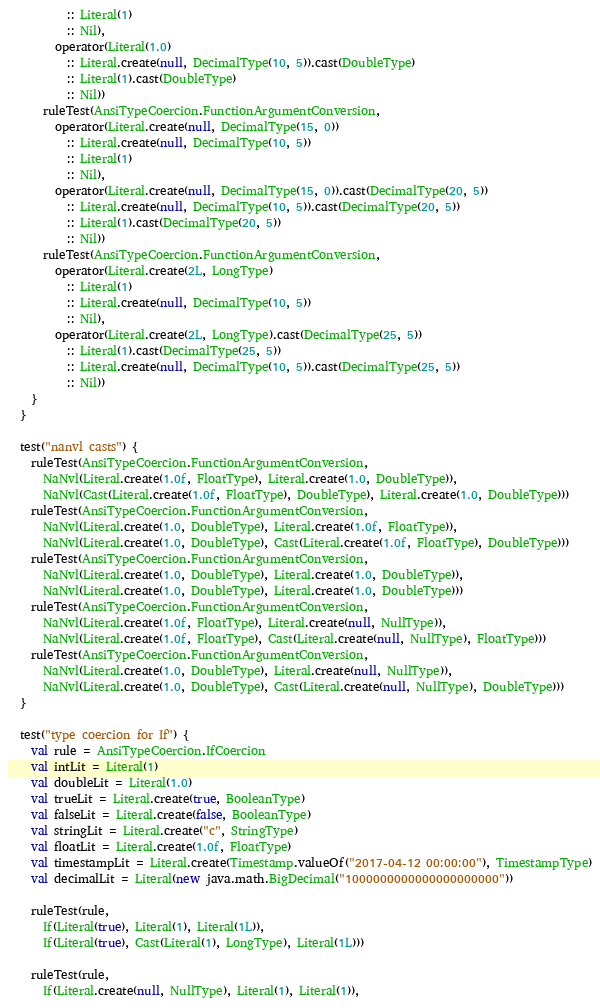<code> <loc_0><loc_0><loc_500><loc_500><_Scala_>          :: Literal(1)
          :: Nil),
        operator(Literal(1.0)
          :: Literal.create(null, DecimalType(10, 5)).cast(DoubleType)
          :: Literal(1).cast(DoubleType)
          :: Nil))
      ruleTest(AnsiTypeCoercion.FunctionArgumentConversion,
        operator(Literal.create(null, DecimalType(15, 0))
          :: Literal.create(null, DecimalType(10, 5))
          :: Literal(1)
          :: Nil),
        operator(Literal.create(null, DecimalType(15, 0)).cast(DecimalType(20, 5))
          :: Literal.create(null, DecimalType(10, 5)).cast(DecimalType(20, 5))
          :: Literal(1).cast(DecimalType(20, 5))
          :: Nil))
      ruleTest(AnsiTypeCoercion.FunctionArgumentConversion,
        operator(Literal.create(2L, LongType)
          :: Literal(1)
          :: Literal.create(null, DecimalType(10, 5))
          :: Nil),
        operator(Literal.create(2L, LongType).cast(DecimalType(25, 5))
          :: Literal(1).cast(DecimalType(25, 5))
          :: Literal.create(null, DecimalType(10, 5)).cast(DecimalType(25, 5))
          :: Nil))
    }
  }

  test("nanvl casts") {
    ruleTest(AnsiTypeCoercion.FunctionArgumentConversion,
      NaNvl(Literal.create(1.0f, FloatType), Literal.create(1.0, DoubleType)),
      NaNvl(Cast(Literal.create(1.0f, FloatType), DoubleType), Literal.create(1.0, DoubleType)))
    ruleTest(AnsiTypeCoercion.FunctionArgumentConversion,
      NaNvl(Literal.create(1.0, DoubleType), Literal.create(1.0f, FloatType)),
      NaNvl(Literal.create(1.0, DoubleType), Cast(Literal.create(1.0f, FloatType), DoubleType)))
    ruleTest(AnsiTypeCoercion.FunctionArgumentConversion,
      NaNvl(Literal.create(1.0, DoubleType), Literal.create(1.0, DoubleType)),
      NaNvl(Literal.create(1.0, DoubleType), Literal.create(1.0, DoubleType)))
    ruleTest(AnsiTypeCoercion.FunctionArgumentConversion,
      NaNvl(Literal.create(1.0f, FloatType), Literal.create(null, NullType)),
      NaNvl(Literal.create(1.0f, FloatType), Cast(Literal.create(null, NullType), FloatType)))
    ruleTest(AnsiTypeCoercion.FunctionArgumentConversion,
      NaNvl(Literal.create(1.0, DoubleType), Literal.create(null, NullType)),
      NaNvl(Literal.create(1.0, DoubleType), Cast(Literal.create(null, NullType), DoubleType)))
  }

  test("type coercion for If") {
    val rule = AnsiTypeCoercion.IfCoercion
    val intLit = Literal(1)
    val doubleLit = Literal(1.0)
    val trueLit = Literal.create(true, BooleanType)
    val falseLit = Literal.create(false, BooleanType)
    val stringLit = Literal.create("c", StringType)
    val floatLit = Literal.create(1.0f, FloatType)
    val timestampLit = Literal.create(Timestamp.valueOf("2017-04-12 00:00:00"), TimestampType)
    val decimalLit = Literal(new java.math.BigDecimal("1000000000000000000000"))

    ruleTest(rule,
      If(Literal(true), Literal(1), Literal(1L)),
      If(Literal(true), Cast(Literal(1), LongType), Literal(1L)))

    ruleTest(rule,
      If(Literal.create(null, NullType), Literal(1), Literal(1)),</code> 